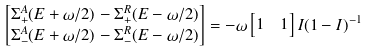Convert formula to latex. <formula><loc_0><loc_0><loc_500><loc_500>& \begin{bmatrix} \Sigma ^ { A } _ { + } ( E + \omega / 2 ) - \Sigma ^ { R } _ { + } ( E - \omega / 2 ) \\ \Sigma ^ { A } _ { - } ( E + \omega / 2 ) - \Sigma ^ { R } _ { - } ( E - \omega / 2 ) \end{bmatrix} = - \omega \begin{bmatrix} 1 & 1 \end{bmatrix} I ( 1 - I ) ^ { - 1 }</formula> 